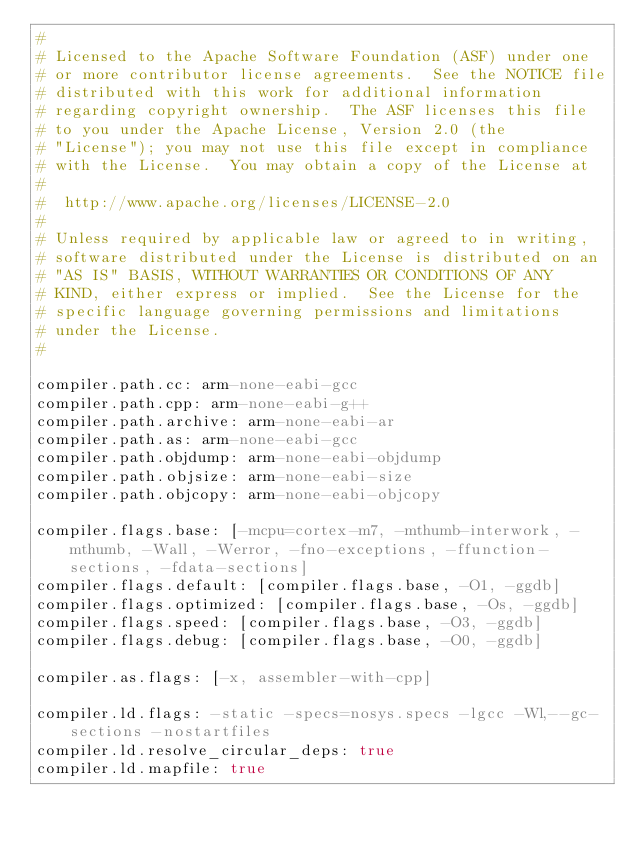<code> <loc_0><loc_0><loc_500><loc_500><_YAML_>#
# Licensed to the Apache Software Foundation (ASF) under one
# or more contributor license agreements.  See the NOTICE file
# distributed with this work for additional information
# regarding copyright ownership.  The ASF licenses this file
# to you under the Apache License, Version 2.0 (the
# "License"); you may not use this file except in compliance
# with the License.  You may obtain a copy of the License at
# 
#  http://www.apache.org/licenses/LICENSE-2.0
#
# Unless required by applicable law or agreed to in writing,
# software distributed under the License is distributed on an
# "AS IS" BASIS, WITHOUT WARRANTIES OR CONDITIONS OF ANY
# KIND, either express or implied.  See the License for the
# specific language governing permissions and limitations
# under the License.
#

compiler.path.cc: arm-none-eabi-gcc
compiler.path.cpp: arm-none-eabi-g++
compiler.path.archive: arm-none-eabi-ar
compiler.path.as: arm-none-eabi-gcc
compiler.path.objdump: arm-none-eabi-objdump
compiler.path.objsize: arm-none-eabi-size
compiler.path.objcopy: arm-none-eabi-objcopy

compiler.flags.base: [-mcpu=cortex-m7, -mthumb-interwork, -mthumb, -Wall, -Werror, -fno-exceptions, -ffunction-sections, -fdata-sections]
compiler.flags.default: [compiler.flags.base, -O1, -ggdb]
compiler.flags.optimized: [compiler.flags.base, -Os, -ggdb]
compiler.flags.speed: [compiler.flags.base, -O3, -ggdb]
compiler.flags.debug: [compiler.flags.base, -O0, -ggdb]

compiler.as.flags: [-x, assembler-with-cpp]

compiler.ld.flags: -static -specs=nosys.specs -lgcc -Wl,--gc-sections -nostartfiles
compiler.ld.resolve_circular_deps: true
compiler.ld.mapfile: true
</code> 